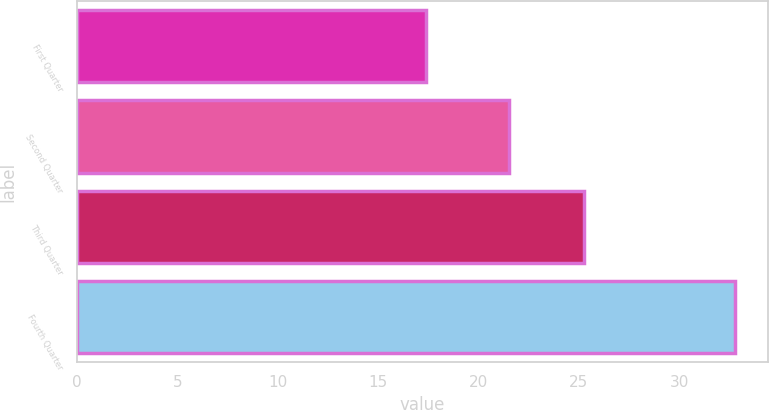<chart> <loc_0><loc_0><loc_500><loc_500><bar_chart><fcel>First Quarter<fcel>Second Quarter<fcel>Third Quarter<fcel>Fourth Quarter<nl><fcel>17.4<fcel>21.49<fcel>25.27<fcel>32.77<nl></chart> 